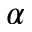<formula> <loc_0><loc_0><loc_500><loc_500>\alpha</formula> 